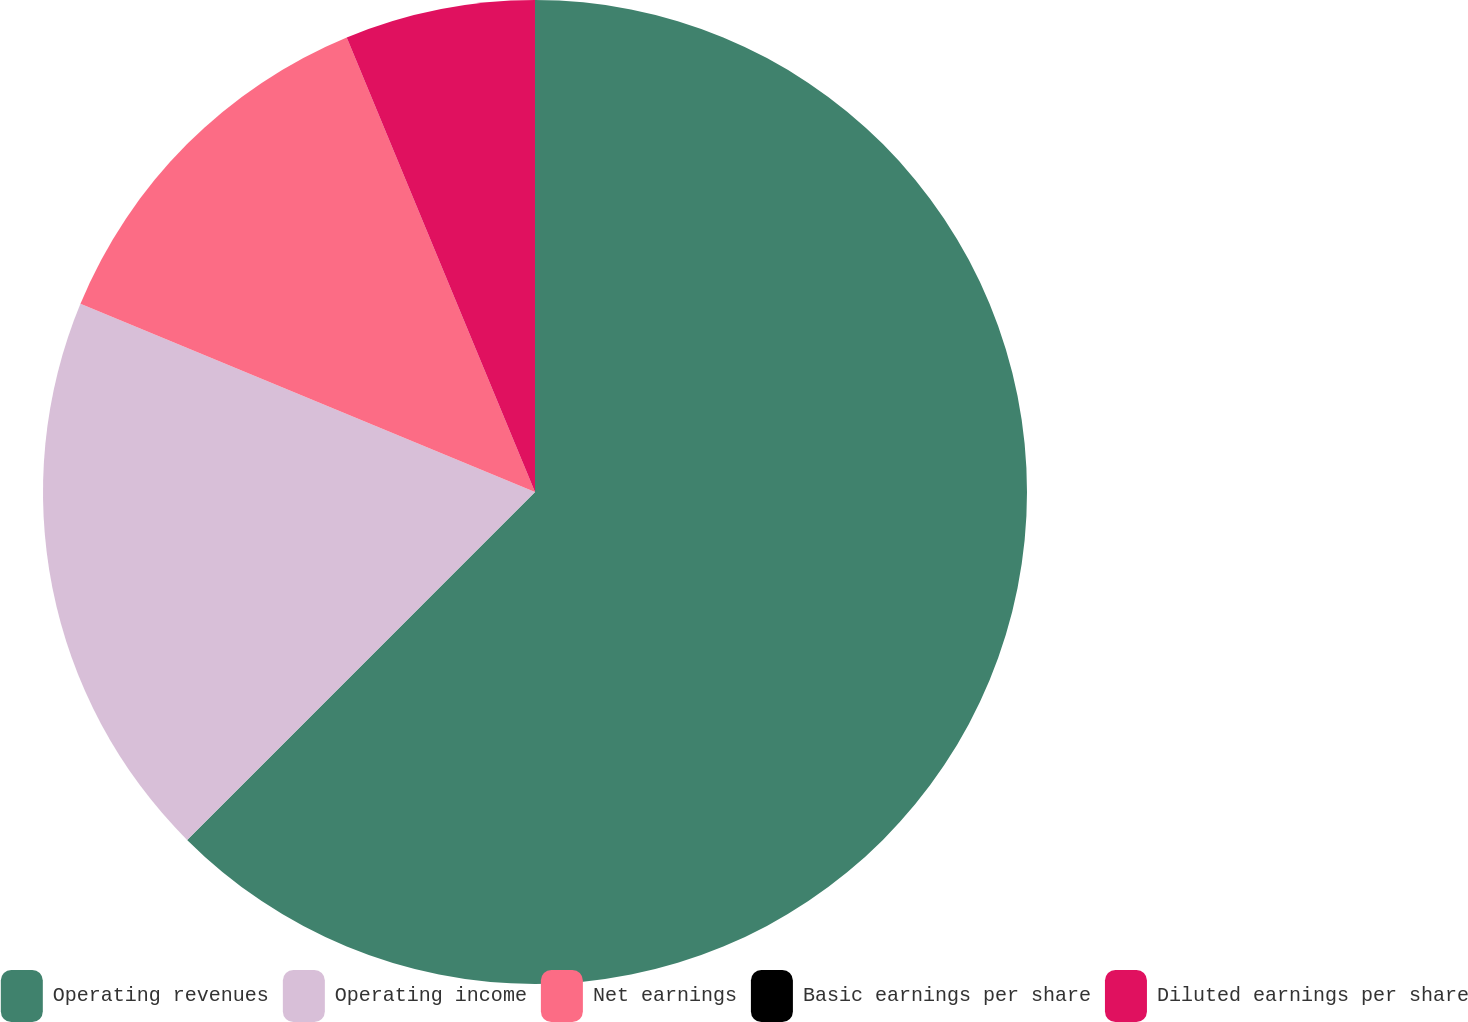<chart> <loc_0><loc_0><loc_500><loc_500><pie_chart><fcel>Operating revenues<fcel>Operating income<fcel>Net earnings<fcel>Basic earnings per share<fcel>Diluted earnings per share<nl><fcel>62.5%<fcel>18.75%<fcel>12.5%<fcel>0.0%<fcel>6.25%<nl></chart> 